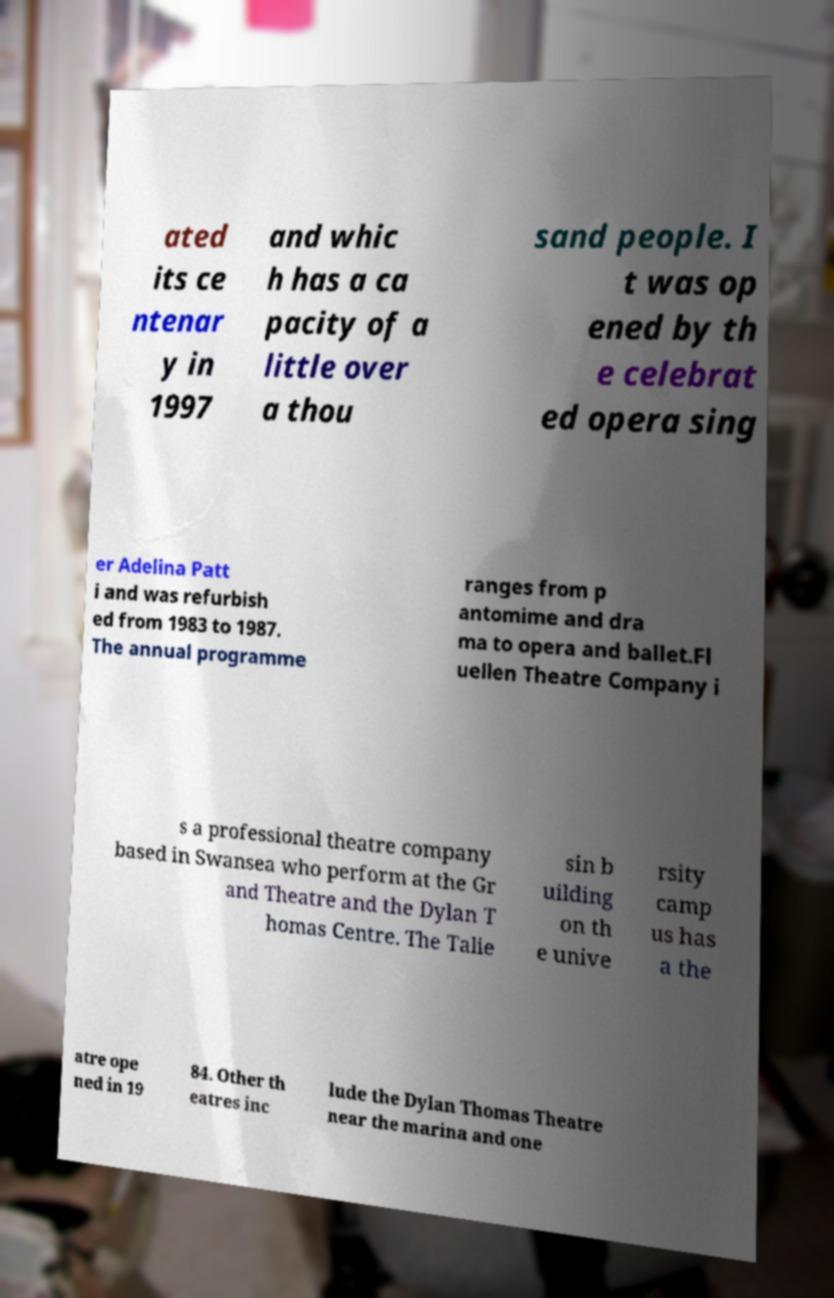Could you extract and type out the text from this image? ated its ce ntenar y in 1997 and whic h has a ca pacity of a little over a thou sand people. I t was op ened by th e celebrat ed opera sing er Adelina Patt i and was refurbish ed from 1983 to 1987. The annual programme ranges from p antomime and dra ma to opera and ballet.Fl uellen Theatre Company i s a professional theatre company based in Swansea who perform at the Gr and Theatre and the Dylan T homas Centre. The Talie sin b uilding on th e unive rsity camp us has a the atre ope ned in 19 84. Other th eatres inc lude the Dylan Thomas Theatre near the marina and one 